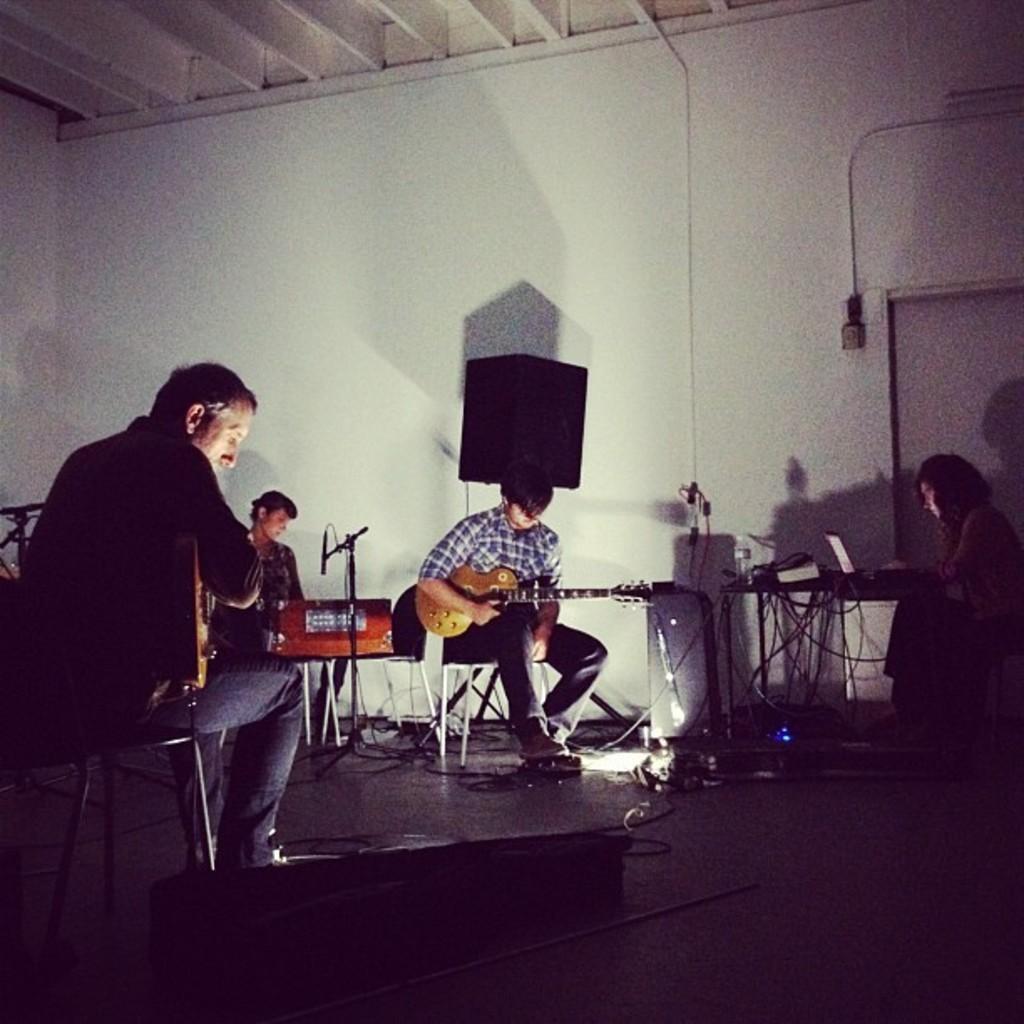Could you give a brief overview of what you see in this image? there are people sitting on the chair , holding guitar in their hands. the person at the right is operating the laptop. at the back there is a speaker. 